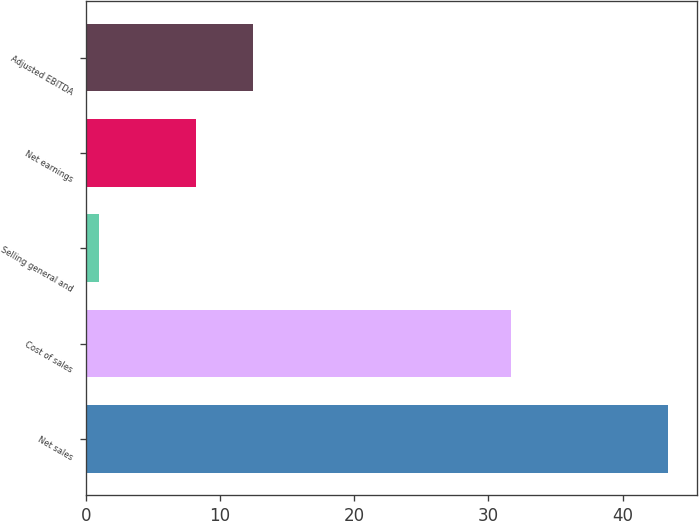Convert chart to OTSL. <chart><loc_0><loc_0><loc_500><loc_500><bar_chart><fcel>Net sales<fcel>Cost of sales<fcel>Selling general and<fcel>Net earnings<fcel>Adjusted EBITDA<nl><fcel>43.4<fcel>31.7<fcel>1<fcel>8.2<fcel>12.44<nl></chart> 